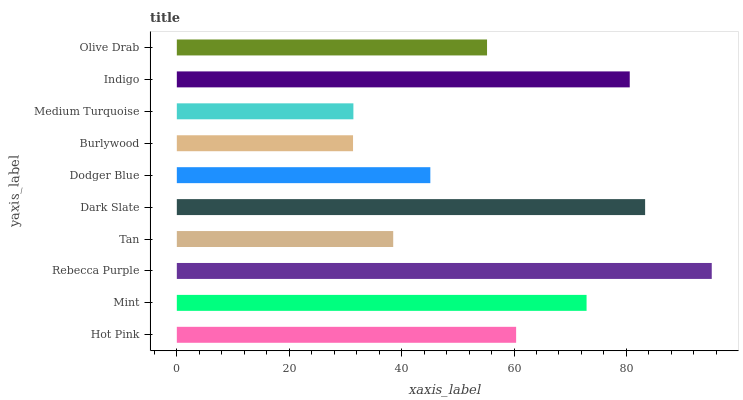Is Burlywood the minimum?
Answer yes or no. Yes. Is Rebecca Purple the maximum?
Answer yes or no. Yes. Is Mint the minimum?
Answer yes or no. No. Is Mint the maximum?
Answer yes or no. No. Is Mint greater than Hot Pink?
Answer yes or no. Yes. Is Hot Pink less than Mint?
Answer yes or no. Yes. Is Hot Pink greater than Mint?
Answer yes or no. No. Is Mint less than Hot Pink?
Answer yes or no. No. Is Hot Pink the high median?
Answer yes or no. Yes. Is Olive Drab the low median?
Answer yes or no. Yes. Is Medium Turquoise the high median?
Answer yes or no. No. Is Mint the low median?
Answer yes or no. No. 